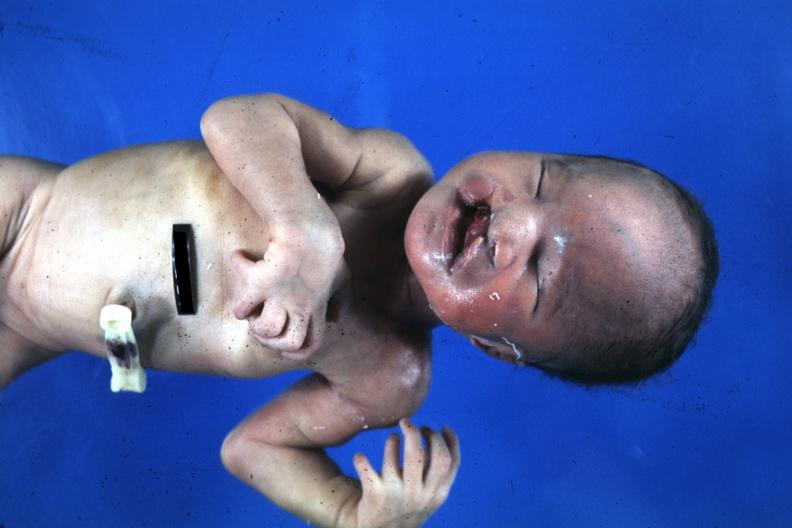s lymphangiomatosis present?
Answer the question using a single word or phrase. No 